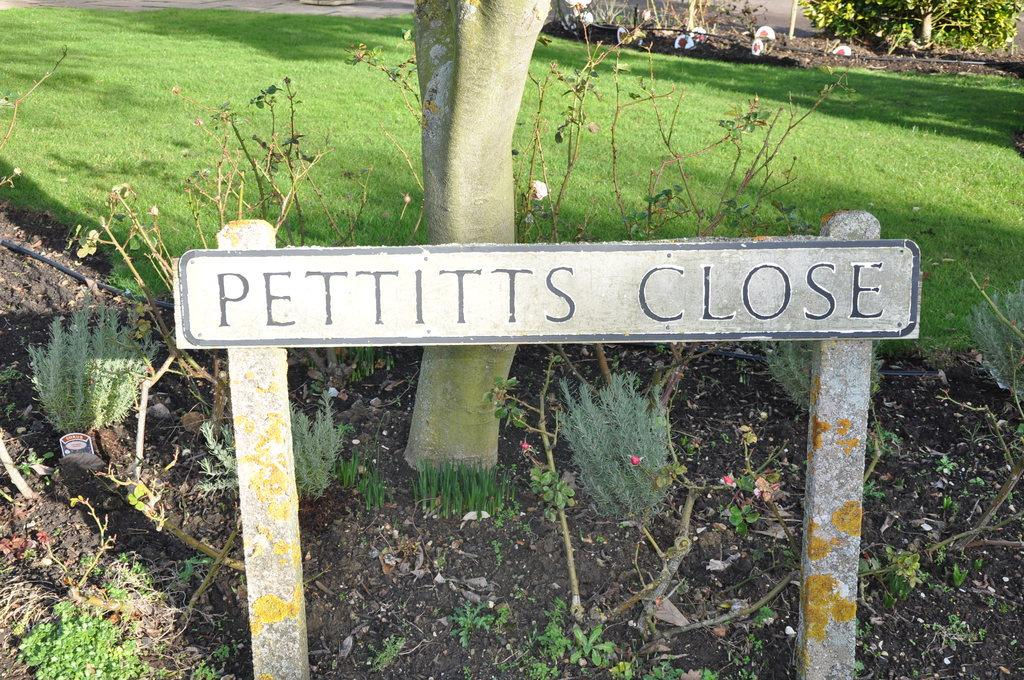What type of vegetation can be seen in the image? There are trees and plants in the image. What else is present in the image besides vegetation? There is a board with writing in the image. What type of sound can be heard coming from the brass instrument in the image? There is no brass instrument present in the image, so it is not possible to determine what, if any, sound might be heard. 